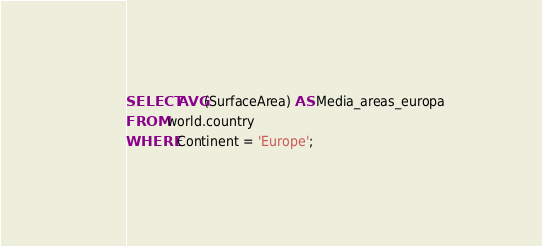<code> <loc_0><loc_0><loc_500><loc_500><_SQL_>SELECT AVG(SurfaceArea) AS Media_areas_europa 
FROM world.country 
WHERE Continent = 'Europe';</code> 